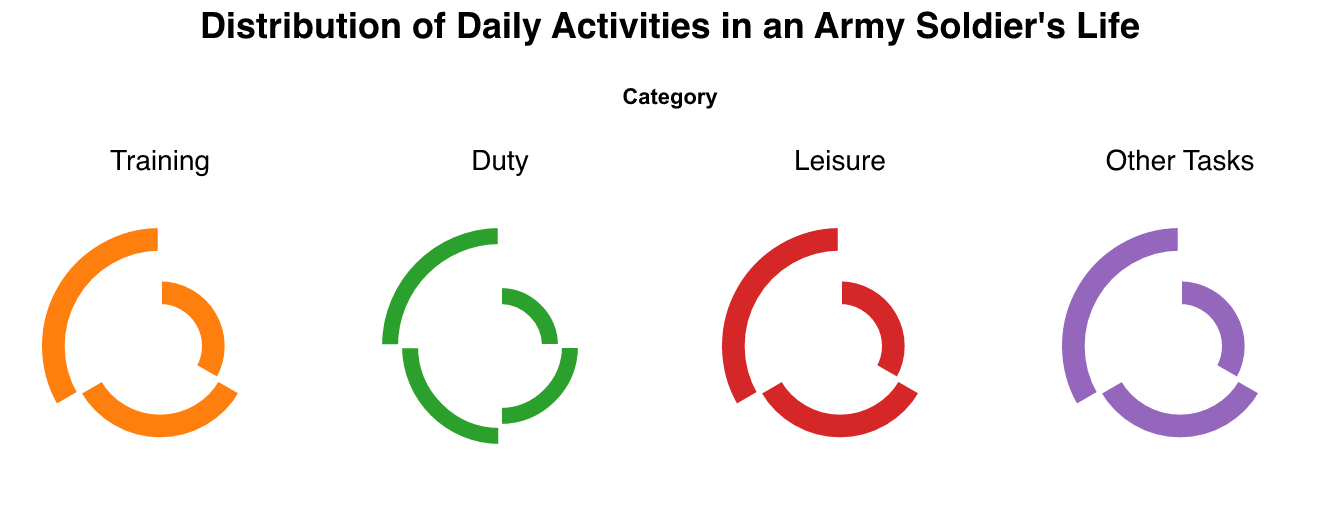What's the title of the figure? The title of the figure is displayed at the top and clearly states the purpose of the plot.
Answer: Distribution of Daily Activities in an Army Soldier's Life How many categories of activities are there? The categories of activities are shown as columns in the subplot of the Polar Chart. Counting the unique columns reveals the number of categories.
Answer: 4 Which category represents the most time slots? To find the category with the most time slots, compare the number of activities in each category. The one with the highest count represents the most time slots.
Answer: Duty What training activities are there? Look at the Training category and list all the activities shown in its respective arc.
Answer: Physical Training, Combat Drills (Individual), Combat Simulations (Group) How many activities are in the Leisure category? Count the number of arcs corresponding to the Leisure category in the subplot.
Answer: 3 Which category has the fewest activities? Compare the number of activities in each category by counting the arcs under each column. The category with the least arcs has the fewest activities.
Answer: Leisure What activities are listed in the Other Tasks category? Examine the arcs under the Other Tasks category and list all the activities shown.
Answer: Shower and Breakfast, Lunch, Dinner What is the first activity of the day? Identify the arc that corresponds to the earliest time slot (0600) in the Training category.
Answer: Physical Training Which activity comes after Dinner? Look at the arc for 1800 (Dinner) under Other Tasks and then identify the next time slot activity.
Answer: Evening Briefing and Debrief How does the distribution of activities change throughout the day? To answer this, one needs to analyze the time slots across the entire plot and observe the categories. Mornings and afternoons are dominated by Training and Duty, whereas evenings include more Leisure activities.
Answer: Training and Duty dominate the day, Leisure activities are more frequent in the evening 